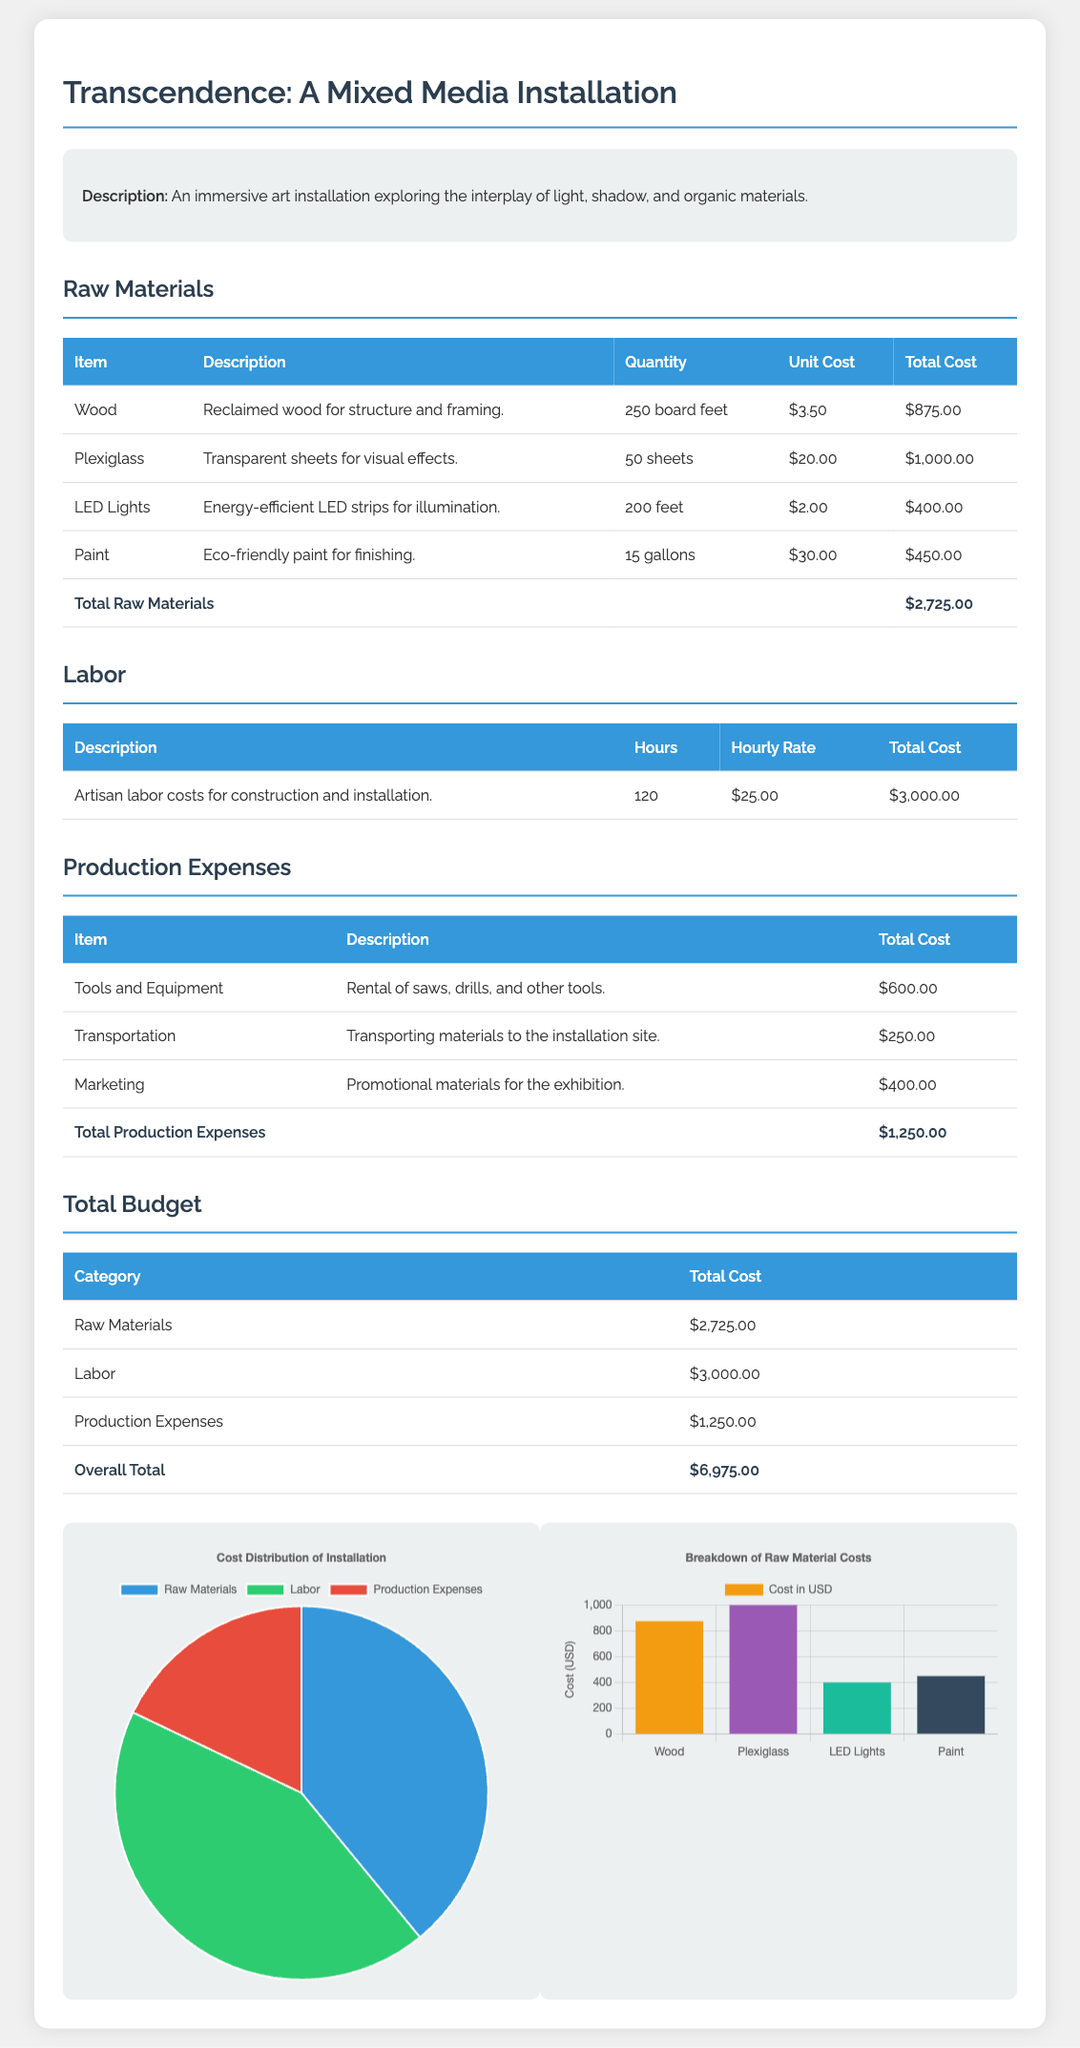What is the total cost of raw materials? The total cost of raw materials is listed in the budget section of the document, which sums up to $2,725.00.
Answer: $2,725.00 How many sheets of Plexiglass were used? The budget details the quantity of Plexiglass used in the project, which is 50 sheets.
Answer: 50 sheets What is the hourly rate for labor? The document states the hourly rate for labor, which is $25.00.
Answer: $25.00 What is the total cost for artisan labor? The total cost for artisan labor is mentioned in the labor section, which amounts to $3,000.00.
Answer: $3,000.00 What percentage of the total budget is allocated to production expenses? The percentage is calculated based on the total production expenses ($1,250.00) relative to the overall total budget ($6,975.00), yielding approximately 17.93%.
Answer: 17.93% What are the total production expenses? The total production expenses are summarized in their respective section in the document, which adds up to $1,250.00.
Answer: $1,250.00 What is the total budget for the project? The overall total budget is clearly stated in the document as $6,975.00.
Answer: $6,975.00 Which item has the highest total cost in raw materials? The highest total cost item in the raw materials section is Plexiglass, valued at $1,000.00.
Answer: Plexiglass What is the total number of hours for labor? The document specifies the total hours worked for labor as 120 hours.
Answer: 120 hours What is the cost of transportation in production expenses? The transportation cost is specifically noted in the table under production expenses, which is $250.00.
Answer: $250.00 